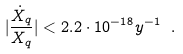<formula> <loc_0><loc_0><loc_500><loc_500>| \frac { { \dot { X } } _ { q } } { X _ { q } } | < 2 . 2 \cdot 1 0 ^ { - 1 8 } y ^ { - 1 } \ .</formula> 